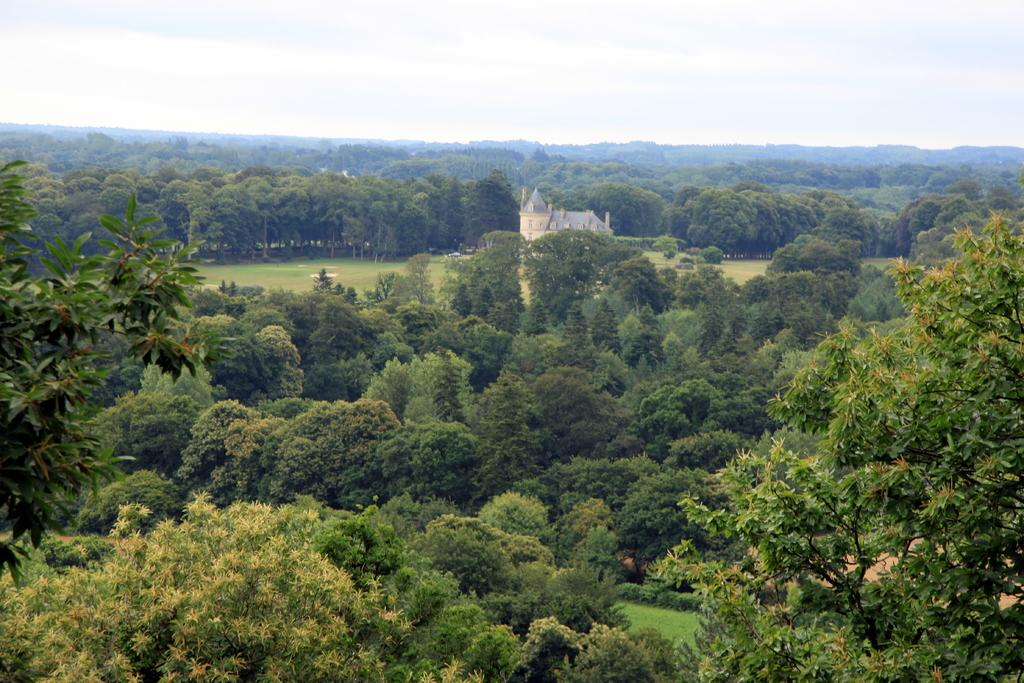What type of structure is visible in the image? There is a building in the image. What other natural elements can be seen in the image? There are trees in the image. How would you describe the weather based on the image? The sky is cloudy in the image, suggesting a potentially overcast or cloudy day. Can you tell me how many times the person sneezes in the image? There is no person present in the image, and therefore no sneezing can be observed. What type of branch is hanging from the building in the image? There is no branch hanging from the building in the image. 